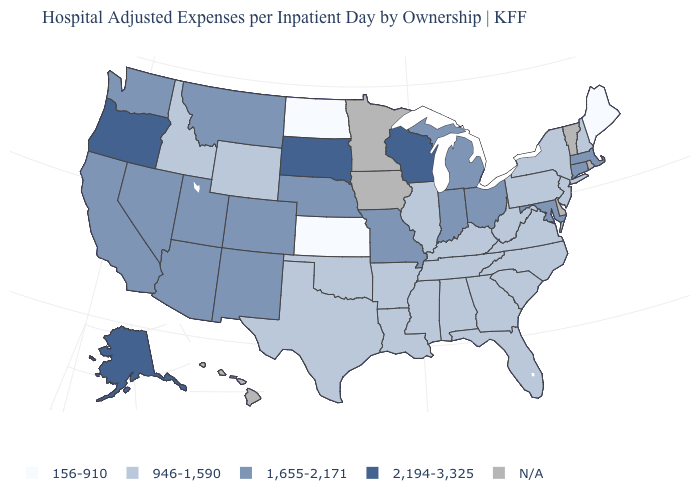What is the value of Rhode Island?
Short answer required. N/A. What is the value of West Virginia?
Write a very short answer. 946-1,590. Which states hav the highest value in the West?
Answer briefly. Alaska, Oregon. What is the value of Idaho?
Concise answer only. 946-1,590. Does Maine have the lowest value in the USA?
Quick response, please. Yes. Among the states that border Indiana , does Ohio have the lowest value?
Keep it brief. No. What is the value of Vermont?
Quick response, please. N/A. What is the value of Oregon?
Short answer required. 2,194-3,325. What is the highest value in states that border Wisconsin?
Answer briefly. 1,655-2,171. What is the value of Montana?
Short answer required. 1,655-2,171. Name the states that have a value in the range N/A?
Concise answer only. Delaware, Hawaii, Iowa, Minnesota, Rhode Island, Vermont. What is the highest value in the MidWest ?
Concise answer only. 2,194-3,325. What is the value of New York?
Answer briefly. 946-1,590. What is the value of Kansas?
Write a very short answer. 156-910. What is the value of Maine?
Answer briefly. 156-910. 